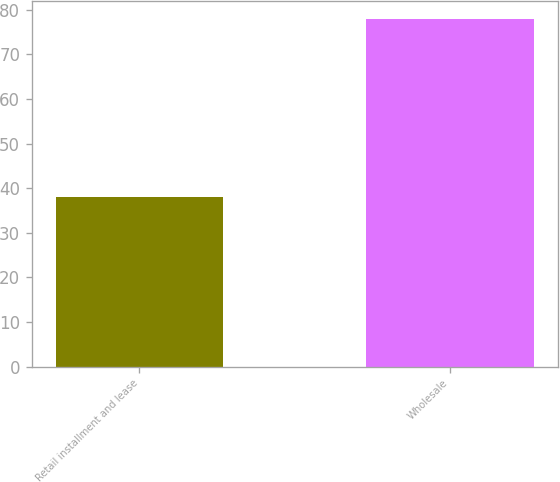Convert chart. <chart><loc_0><loc_0><loc_500><loc_500><bar_chart><fcel>Retail installment and lease<fcel>Wholesale<nl><fcel>38<fcel>78<nl></chart> 